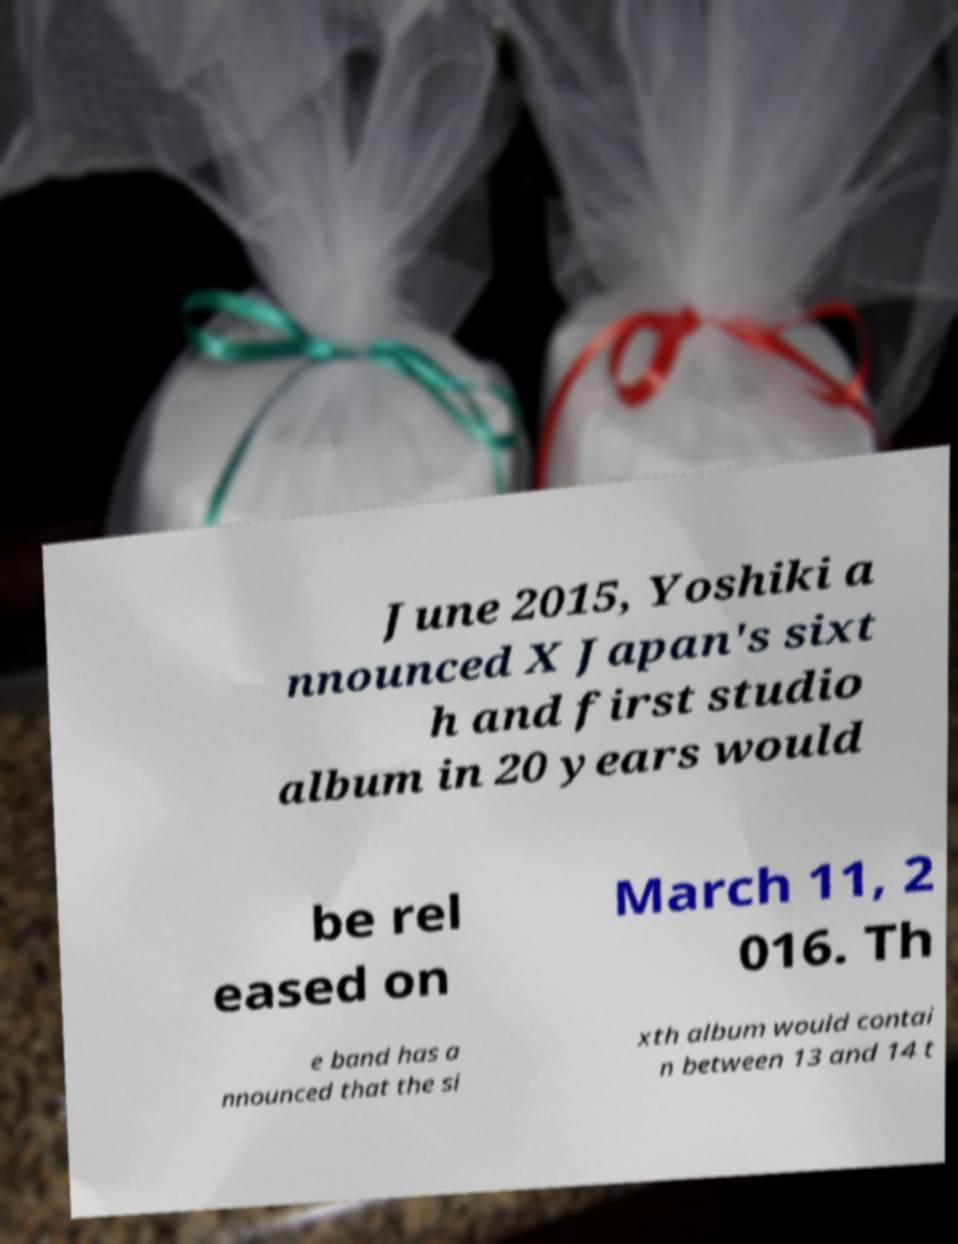Please read and relay the text visible in this image. What does it say? June 2015, Yoshiki a nnounced X Japan's sixt h and first studio album in 20 years would be rel eased on March 11, 2 016. Th e band has a nnounced that the si xth album would contai n between 13 and 14 t 